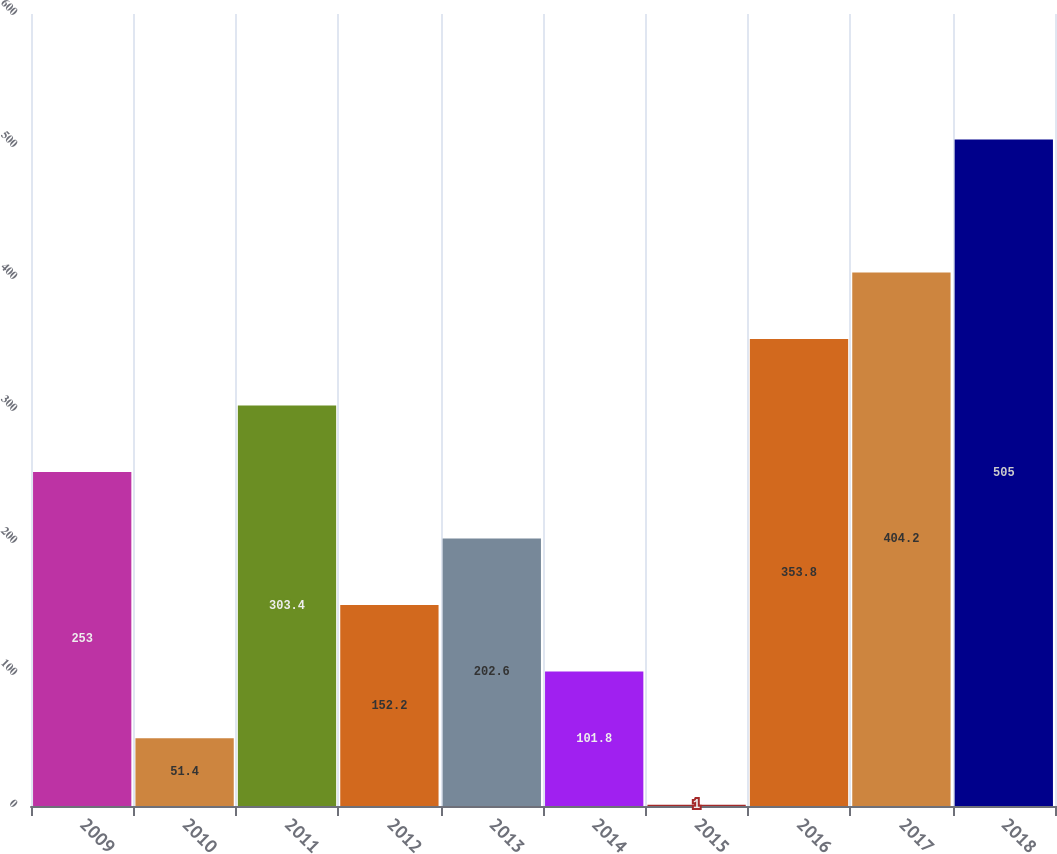Convert chart. <chart><loc_0><loc_0><loc_500><loc_500><bar_chart><fcel>2009<fcel>2010<fcel>2011<fcel>2012<fcel>2013<fcel>2014<fcel>2015<fcel>2016<fcel>2017<fcel>2018<nl><fcel>253<fcel>51.4<fcel>303.4<fcel>152.2<fcel>202.6<fcel>101.8<fcel>1<fcel>353.8<fcel>404.2<fcel>505<nl></chart> 